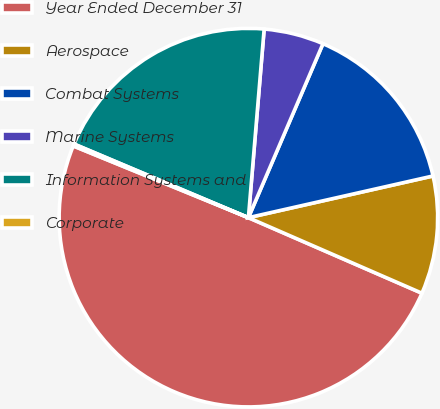<chart> <loc_0><loc_0><loc_500><loc_500><pie_chart><fcel>Year Ended December 31<fcel>Aerospace<fcel>Combat Systems<fcel>Marine Systems<fcel>Information Systems and<fcel>Corporate<nl><fcel>49.65%<fcel>10.07%<fcel>15.02%<fcel>5.12%<fcel>19.97%<fcel>0.17%<nl></chart> 